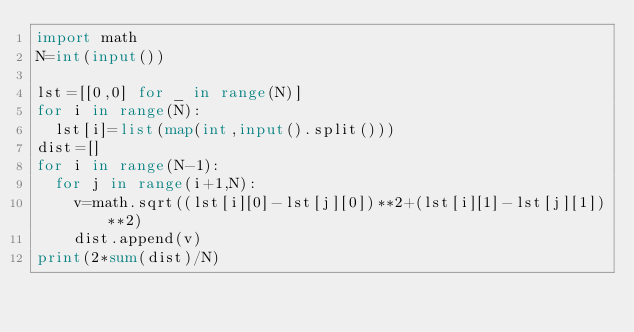<code> <loc_0><loc_0><loc_500><loc_500><_Python_>import math
N=int(input())

lst=[[0,0] for _ in range(N)]
for i in range(N):
  lst[i]=list(map(int,input().split()))
dist=[]
for i in range(N-1):
  for j in range(i+1,N):
    v=math.sqrt((lst[i][0]-lst[j][0])**2+(lst[i][1]-lst[j][1])**2)
    dist.append(v)
print(2*sum(dist)/N)</code> 